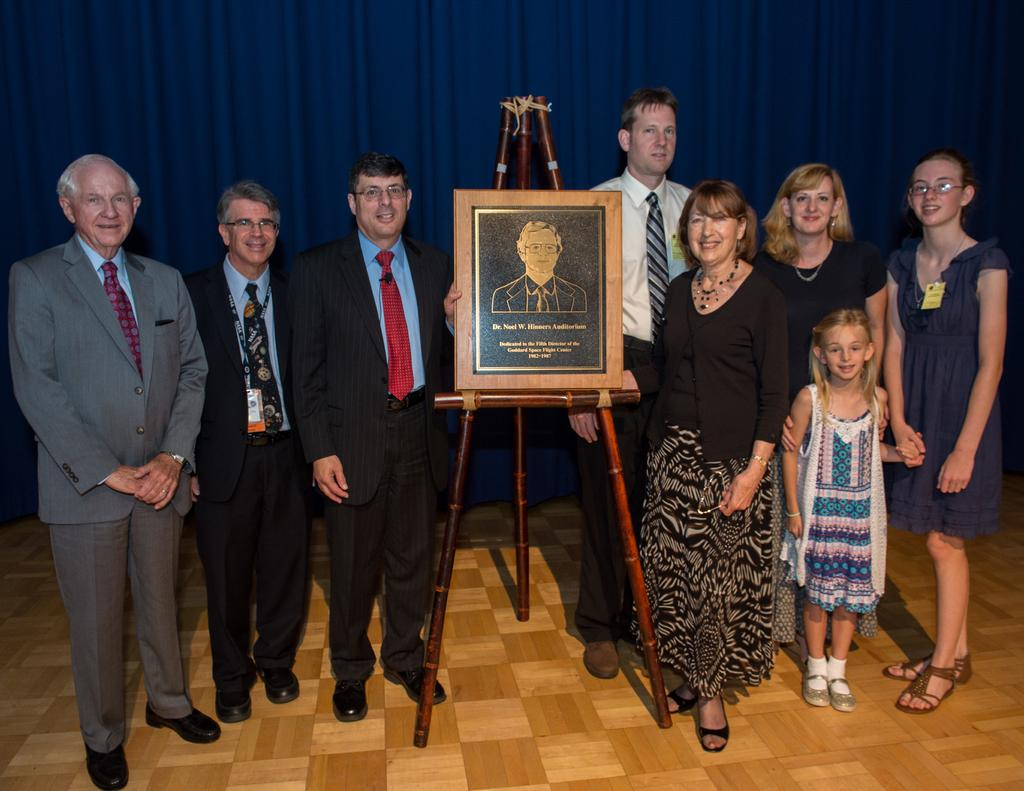What are the people in the image doing? There is a group of people on the floor in the image. What object can be seen on a table in the image? There is a board on a table in the image. What can be seen in the background of the image? There is a curtain visible in the background of the image. What type of milk is being used by the people in the image? There is no milk present in the image; it features a group of people on the floor and a board on a table. How many nails are visible in the image? There are no nails visible in the image. 